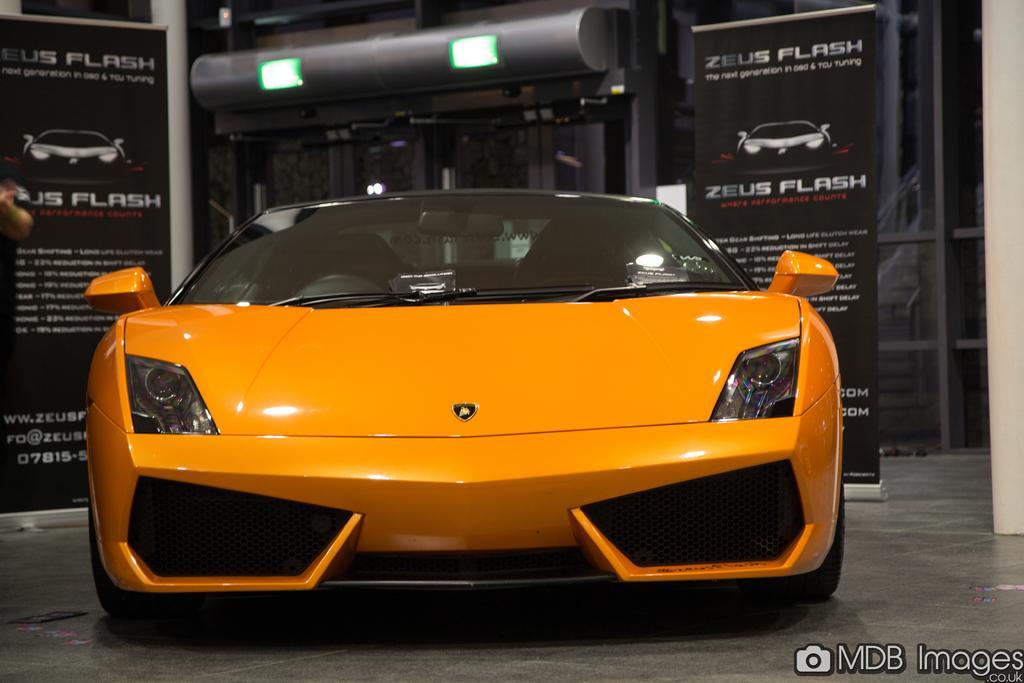In one or two sentences, can you explain what this image depicts? As we can see in the image there is a car, banners and lights. 